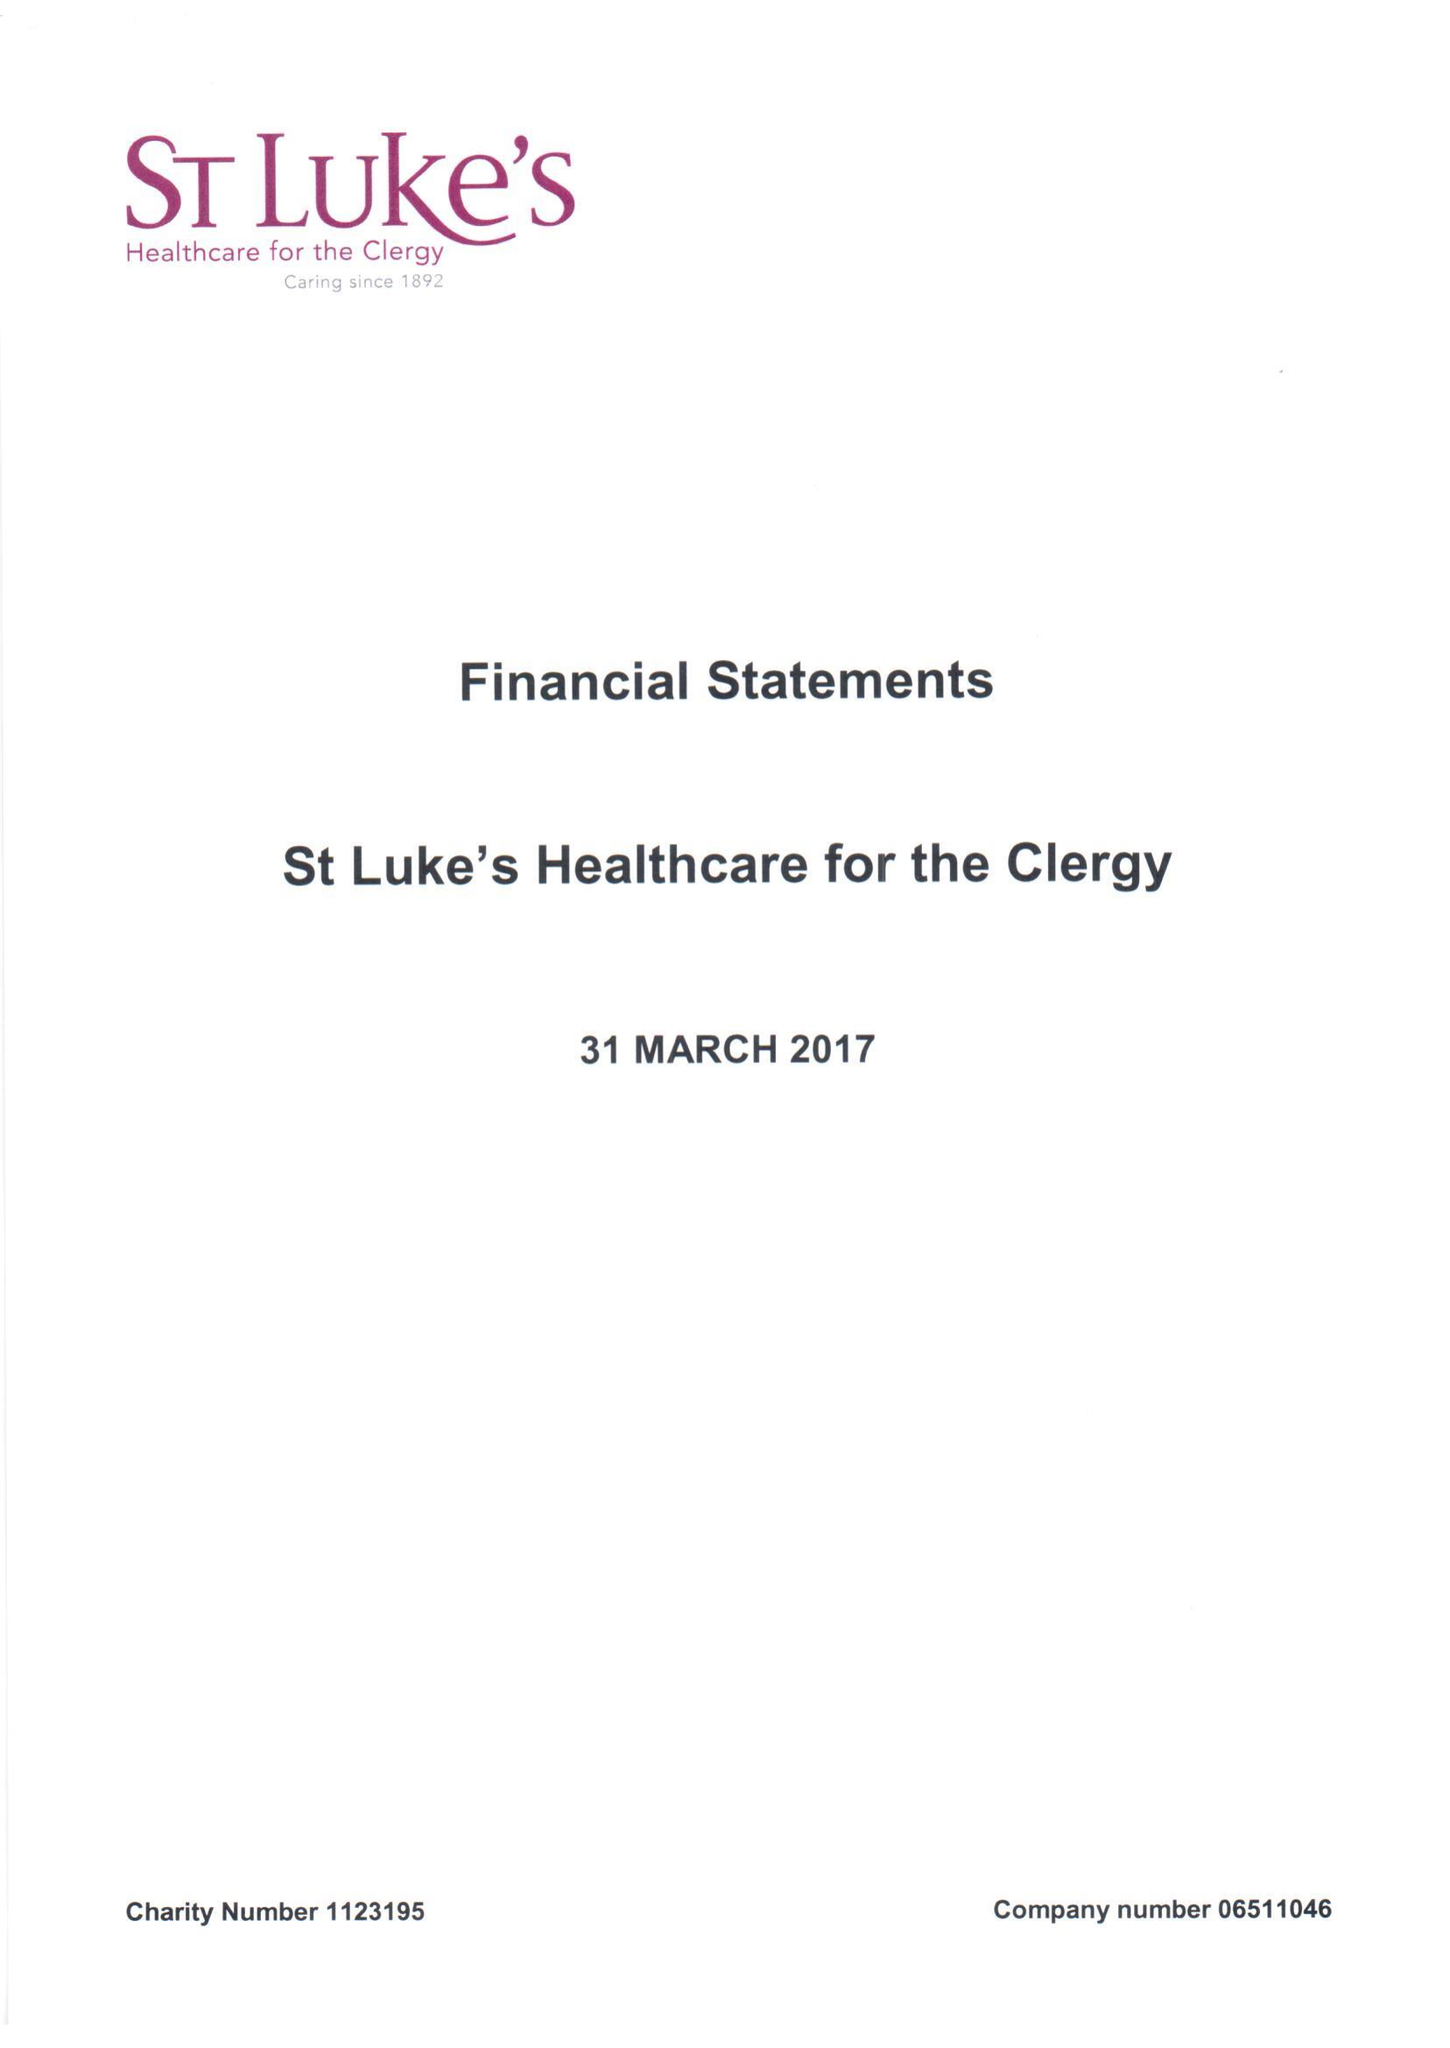What is the value for the charity_name?
Answer the question using a single word or phrase. St Luke's Healthcare For The Clergy 